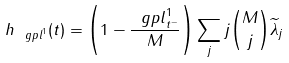<formula> <loc_0><loc_0><loc_500><loc_500>h _ { { \ g p l } ^ { 1 } } ( t ) = \left ( 1 - \frac { { \ g p l } ^ { 1 } _ { t ^ { - } } } { M } \right ) \sum _ { j } j { M \choose j } \widetilde { \lambda } _ { j }</formula> 